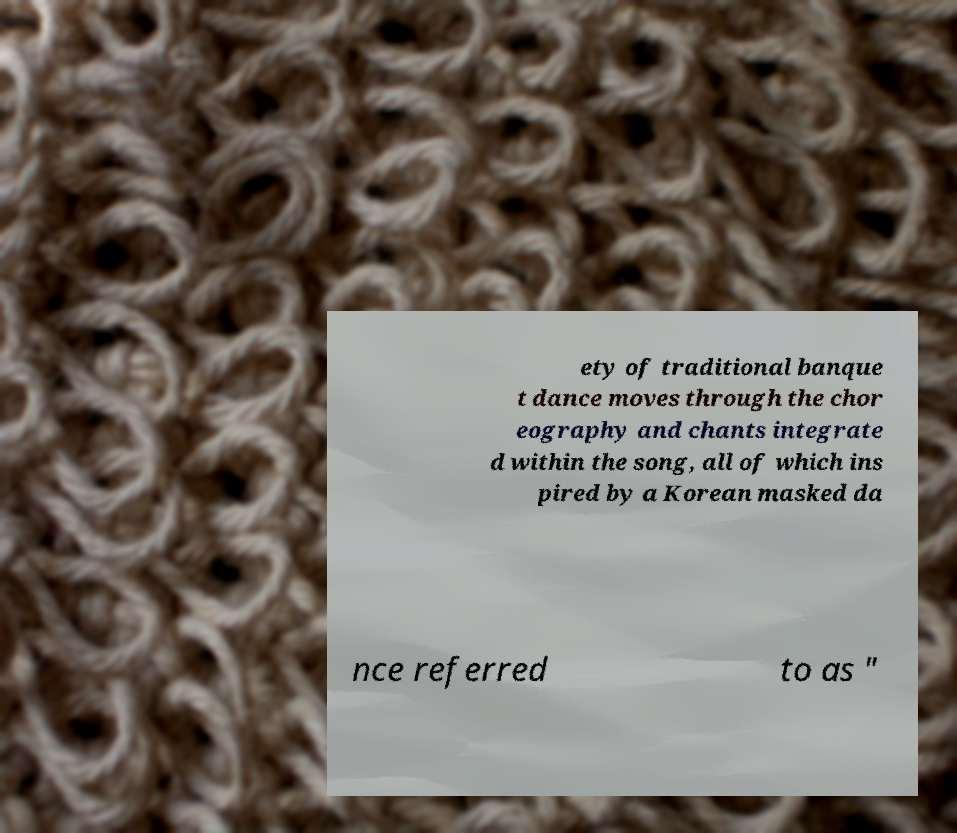I need the written content from this picture converted into text. Can you do that? ety of traditional banque t dance moves through the chor eography and chants integrate d within the song, all of which ins pired by a Korean masked da nce referred to as " 